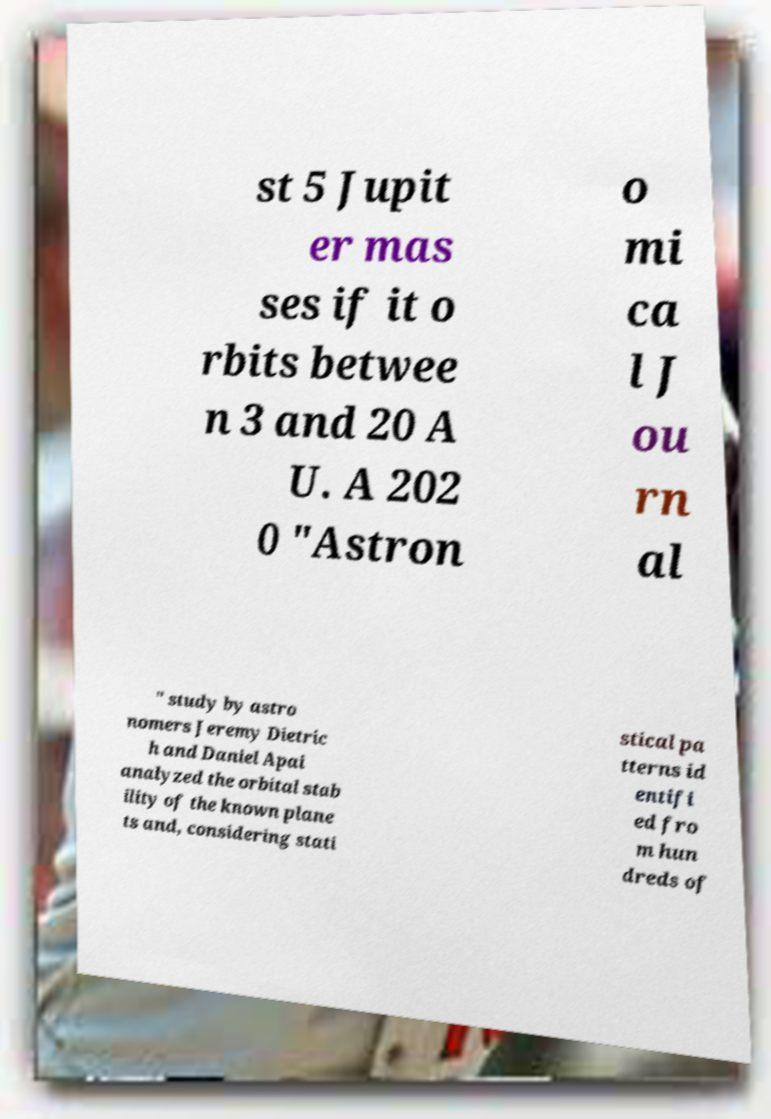What messages or text are displayed in this image? I need them in a readable, typed format. st 5 Jupit er mas ses if it o rbits betwee n 3 and 20 A U. A 202 0 "Astron o mi ca l J ou rn al " study by astro nomers Jeremy Dietric h and Daniel Apai analyzed the orbital stab ility of the known plane ts and, considering stati stical pa tterns id entifi ed fro m hun dreds of 